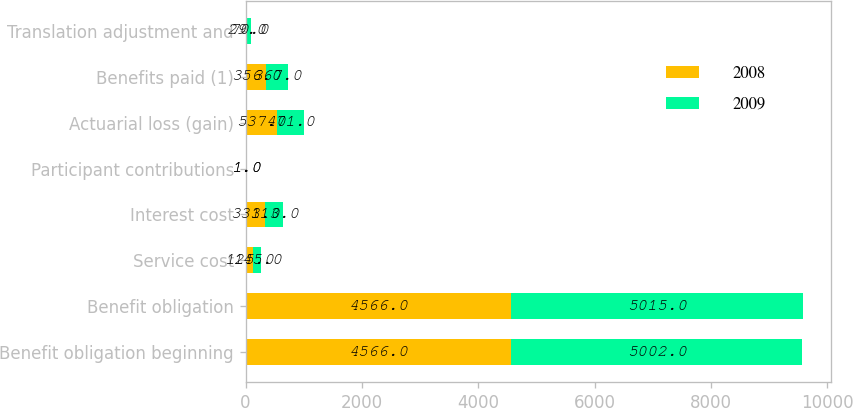Convert chart. <chart><loc_0><loc_0><loc_500><loc_500><stacked_bar_chart><ecel><fcel>Benefit obligation beginning<fcel>Benefit obligation<fcel>Service cost<fcel>Interest cost<fcel>Participant contributions<fcel>Actuarial loss (gain)<fcel>Benefits paid (1)<fcel>Translation adjustment and<nl><fcel>2008<fcel>4566<fcel>4566<fcel>125<fcel>331<fcel>1<fcel>537<fcel>356<fcel>29<nl><fcel>2009<fcel>5002<fcel>5015<fcel>145<fcel>313<fcel>1<fcel>471<fcel>367<fcel>70<nl></chart> 